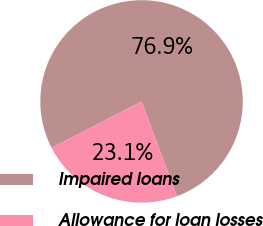Convert chart. <chart><loc_0><loc_0><loc_500><loc_500><pie_chart><fcel>Impaired loans<fcel>Allowance for loan losses<nl><fcel>76.92%<fcel>23.08%<nl></chart> 